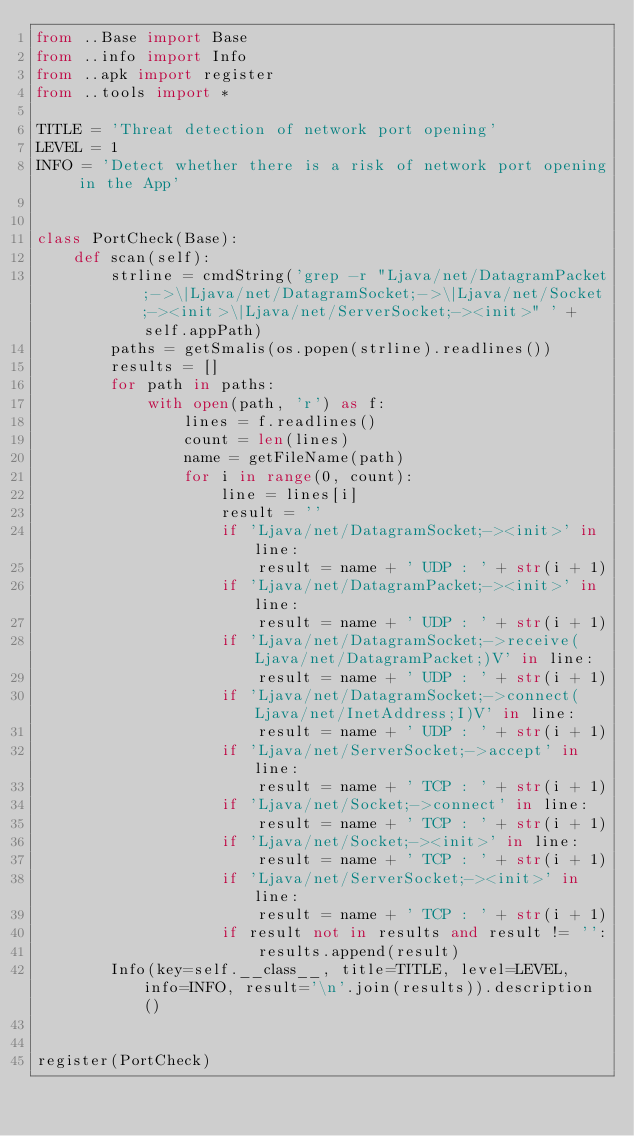<code> <loc_0><loc_0><loc_500><loc_500><_Python_>from ..Base import Base
from ..info import Info
from ..apk import register
from ..tools import *

TITLE = 'Threat detection of network port opening'
LEVEL = 1
INFO = 'Detect whether there is a risk of network port opening in the App'


class PortCheck(Base):
    def scan(self):
        strline = cmdString('grep -r "Ljava/net/DatagramPacket;->\|Ljava/net/DatagramSocket;->\|Ljava/net/Socket;-><init>\|Ljava/net/ServerSocket;-><init>" ' + self.appPath)
        paths = getSmalis(os.popen(strline).readlines())
        results = []
        for path in paths:
            with open(path, 'r') as f:
                lines = f.readlines()
                count = len(lines)
                name = getFileName(path)
                for i in range(0, count):
                    line = lines[i]
                    result = ''
                    if 'Ljava/net/DatagramSocket;-><init>' in line:
                        result = name + ' UDP : ' + str(i + 1)
                    if 'Ljava/net/DatagramPacket;-><init>' in line:
                        result = name + ' UDP : ' + str(i + 1)
                    if 'Ljava/net/DatagramSocket;->receive(Ljava/net/DatagramPacket;)V' in line:
                        result = name + ' UDP : ' + str(i + 1)
                    if 'Ljava/net/DatagramSocket;->connect(Ljava/net/InetAddress;I)V' in line:
                        result = name + ' UDP : ' + str(i + 1)
                    if 'Ljava/net/ServerSocket;->accept' in line:
                        result = name + ' TCP : ' + str(i + 1)
                    if 'Ljava/net/Socket;->connect' in line:
                        result = name + ' TCP : ' + str(i + 1)
                    if 'Ljava/net/Socket;-><init>' in line:
                        result = name + ' TCP : ' + str(i + 1)
                    if 'Ljava/net/ServerSocket;-><init>' in line:
                        result = name + ' TCP : ' + str(i + 1)
                    if result not in results and result != '':
                        results.append(result)
        Info(key=self.__class__, title=TITLE, level=LEVEL, info=INFO, result='\n'.join(results)).description()


register(PortCheck)</code> 